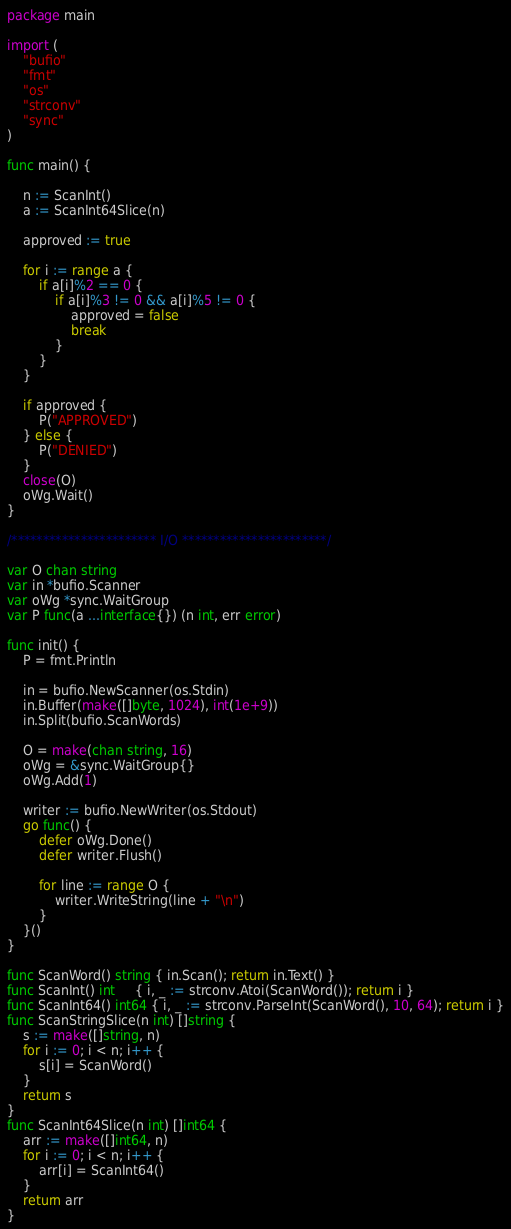Convert code to text. <code><loc_0><loc_0><loc_500><loc_500><_Go_>package main

import (
	"bufio"
	"fmt"
	"os"
	"strconv"
	"sync"
)

func main() {

	n := ScanInt()
	a := ScanInt64Slice(n)

	approved := true

	for i := range a {
		if a[i]%2 == 0 {
			if a[i]%3 != 0 && a[i]%5 != 0 {
				approved = false
				break
			}
		}
	}

	if approved {
		P("APPROVED")
	} else {
		P("DENIED")
	}
	close(O)
	oWg.Wait()
}

/*********************** I/O ***********************/

var O chan string
var in *bufio.Scanner
var oWg *sync.WaitGroup
var P func(a ...interface{}) (n int, err error)

func init() {
	P = fmt.Println

	in = bufio.NewScanner(os.Stdin)
	in.Buffer(make([]byte, 1024), int(1e+9))
	in.Split(bufio.ScanWords)

	O = make(chan string, 16)
	oWg = &sync.WaitGroup{}
	oWg.Add(1)

	writer := bufio.NewWriter(os.Stdout)
	go func() {
		defer oWg.Done()
		defer writer.Flush()

		for line := range O {
			writer.WriteString(line + "\n")
		}
	}()
}

func ScanWord() string { in.Scan(); return in.Text() }
func ScanInt() int     { i, _ := strconv.Atoi(ScanWord()); return i }
func ScanInt64() int64 { i, _ := strconv.ParseInt(ScanWord(), 10, 64); return i }
func ScanStringSlice(n int) []string {
	s := make([]string, n)
	for i := 0; i < n; i++ {
		s[i] = ScanWord()
	}
	return s
}
func ScanInt64Slice(n int) []int64 {
	arr := make([]int64, n)
	for i := 0; i < n; i++ {
		arr[i] = ScanInt64()
	}
	return arr
}
</code> 